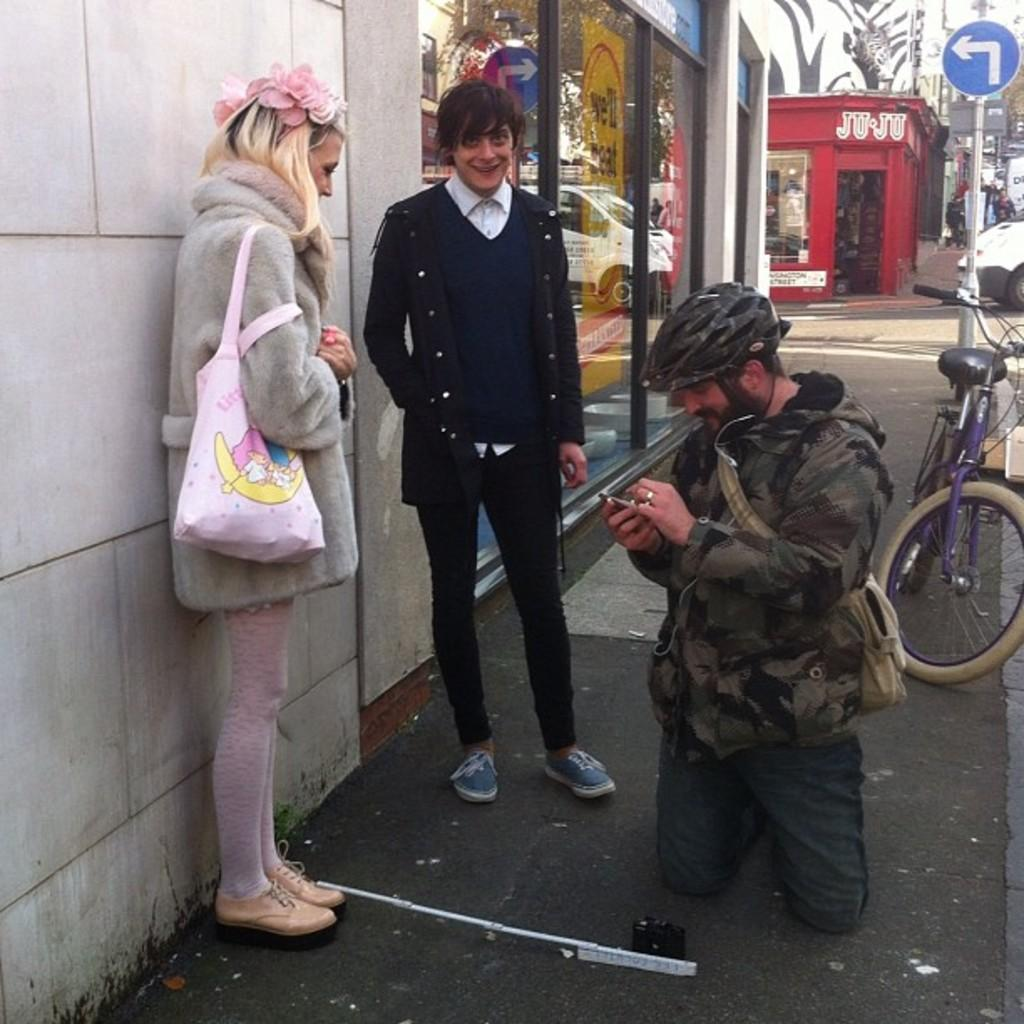What is the main subject of the image? The main subject of the image is a group of people. Where are the people located in the image? The people are standing beside a building. What else can be seen in the image besides the group of people? There is a bicycle parked near a pole in the image. What is visible in the background of the image? There is another building visible in the background of the image. What type of throat-soothing remedy is being offered to the people in the image? There is no throat-soothing remedy present in the image. How many buns are visible in the image? There are no buns visible in the image. 